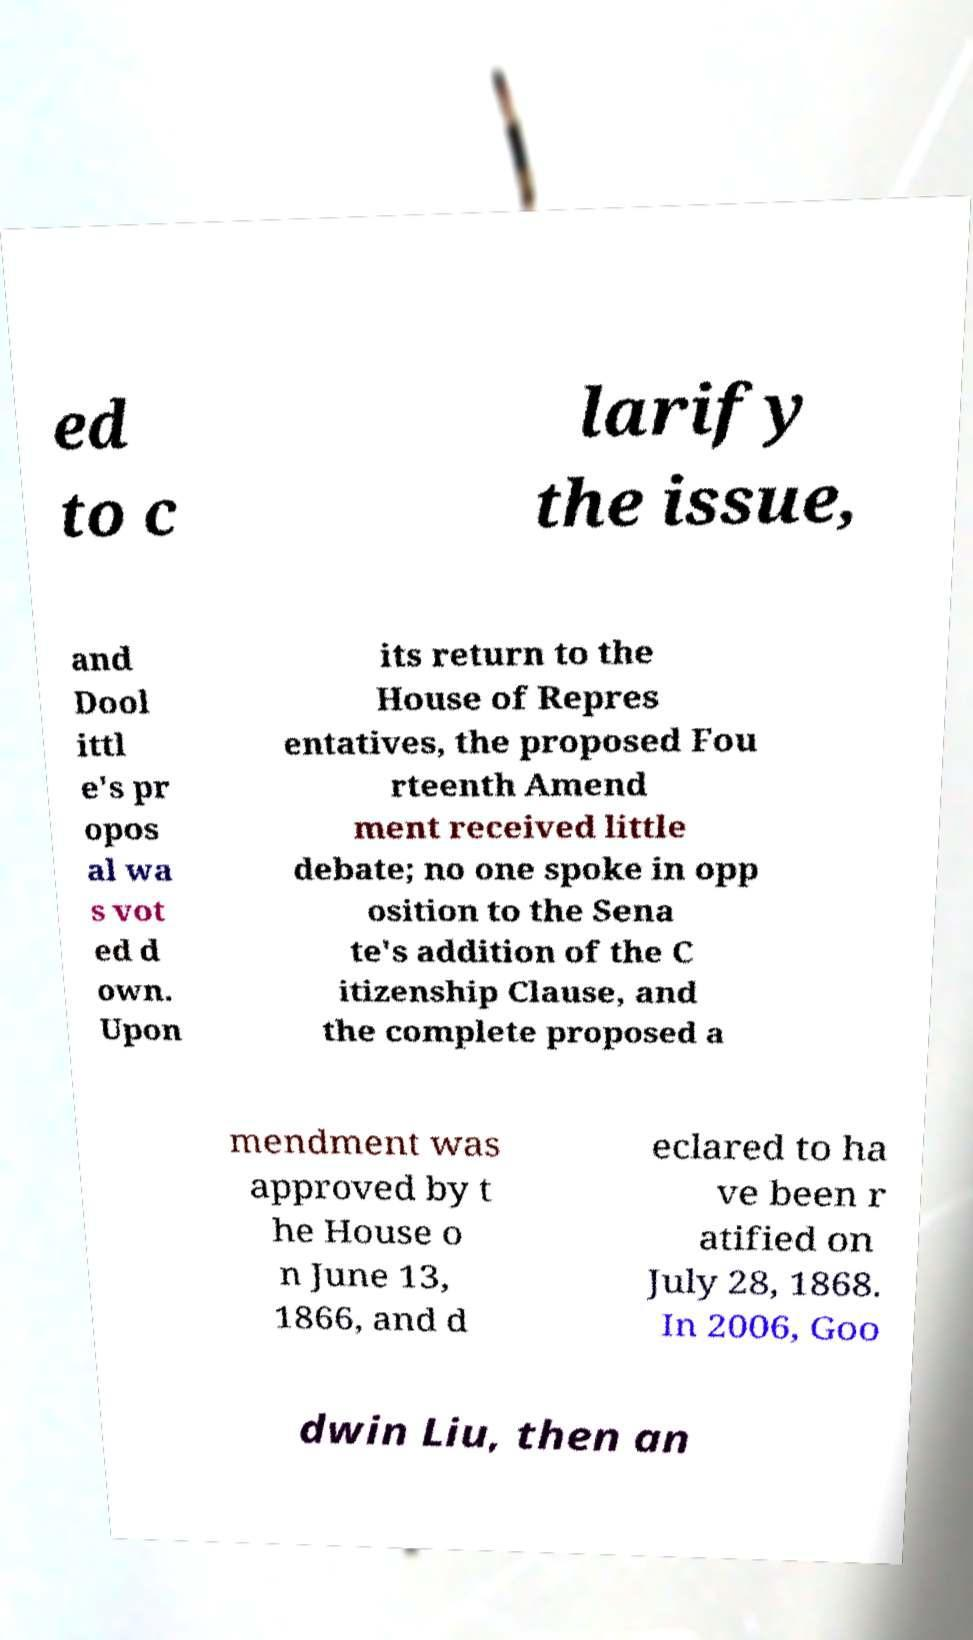Can you read and provide the text displayed in the image?This photo seems to have some interesting text. Can you extract and type it out for me? ed to c larify the issue, and Dool ittl e's pr opos al wa s vot ed d own. Upon its return to the House of Repres entatives, the proposed Fou rteenth Amend ment received little debate; no one spoke in opp osition to the Sena te's addition of the C itizenship Clause, and the complete proposed a mendment was approved by t he House o n June 13, 1866, and d eclared to ha ve been r atified on July 28, 1868. In 2006, Goo dwin Liu, then an 